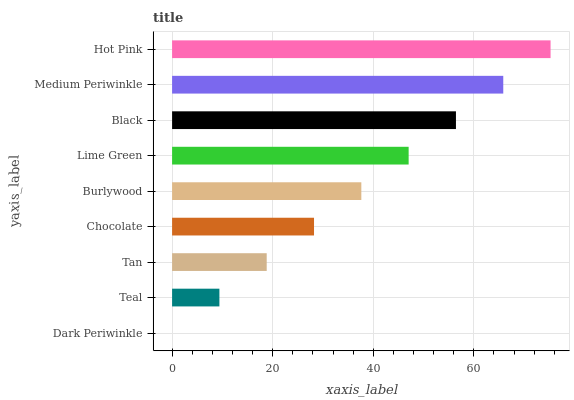Is Dark Periwinkle the minimum?
Answer yes or no. Yes. Is Hot Pink the maximum?
Answer yes or no. Yes. Is Teal the minimum?
Answer yes or no. No. Is Teal the maximum?
Answer yes or no. No. Is Teal greater than Dark Periwinkle?
Answer yes or no. Yes. Is Dark Periwinkle less than Teal?
Answer yes or no. Yes. Is Dark Periwinkle greater than Teal?
Answer yes or no. No. Is Teal less than Dark Periwinkle?
Answer yes or no. No. Is Burlywood the high median?
Answer yes or no. Yes. Is Burlywood the low median?
Answer yes or no. Yes. Is Tan the high median?
Answer yes or no. No. Is Tan the low median?
Answer yes or no. No. 